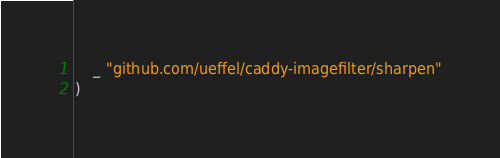Convert code to text. <code><loc_0><loc_0><loc_500><loc_500><_Go_>	_ "github.com/ueffel/caddy-imagefilter/sharpen"
)
</code> 